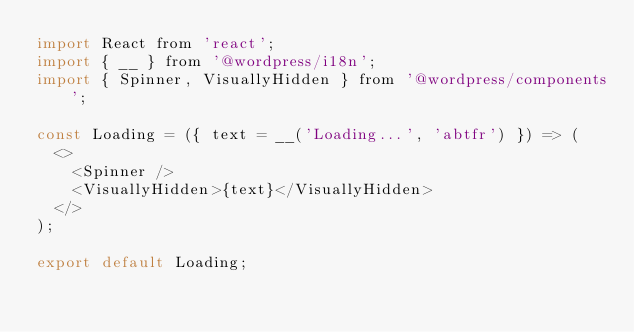<code> <loc_0><loc_0><loc_500><loc_500><_JavaScript_>import React from 'react';
import { __ } from '@wordpress/i18n';
import { Spinner, VisuallyHidden } from '@wordpress/components';

const Loading = ({ text = __('Loading...', 'abtfr') }) => (
  <>
    <Spinner />
    <VisuallyHidden>{text}</VisuallyHidden>
  </>
);

export default Loading;
</code> 